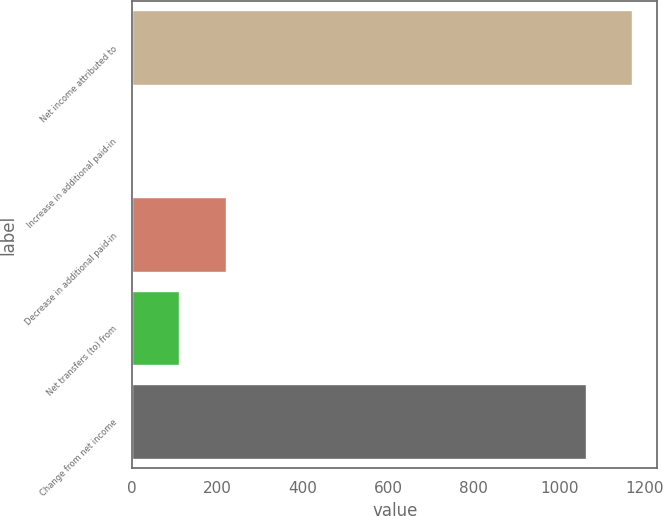Convert chart. <chart><loc_0><loc_0><loc_500><loc_500><bar_chart><fcel>Net income attributed to<fcel>Increase in additional paid-in<fcel>Decrease in additional paid-in<fcel>Net transfers (to) from<fcel>Change from net income<nl><fcel>1171.36<fcel>1.8<fcel>219.12<fcel>110.46<fcel>1062.7<nl></chart> 